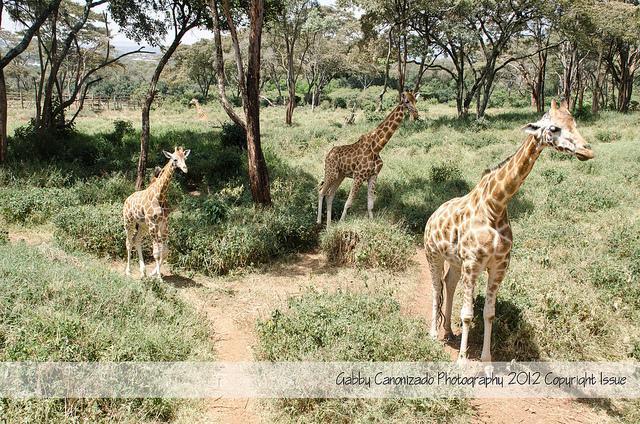How many animals are shown?
Give a very brief answer. 3. How many giraffes are visible?
Give a very brief answer. 3. How many people are wearing a white shirt?
Give a very brief answer. 0. 